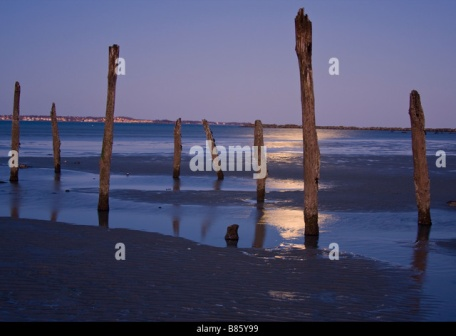If this scene were part of a movie, what would be happening? In a movie, this serene beach scene could be the setting for a pivotal moment of reflection for a protagonist. As dusk falls, the character might be found wandering along the shore, contemplating their past decisions or the future steps they need to take. The weathered poles could serve as metaphors for challenges faced or obstacles yet to come. The quietude and natural beauty of the setting would underscore the internal journey of the character, capturing a moment of clarity, resilience, and resolve as they stand on the precipice of a personal transformation. 